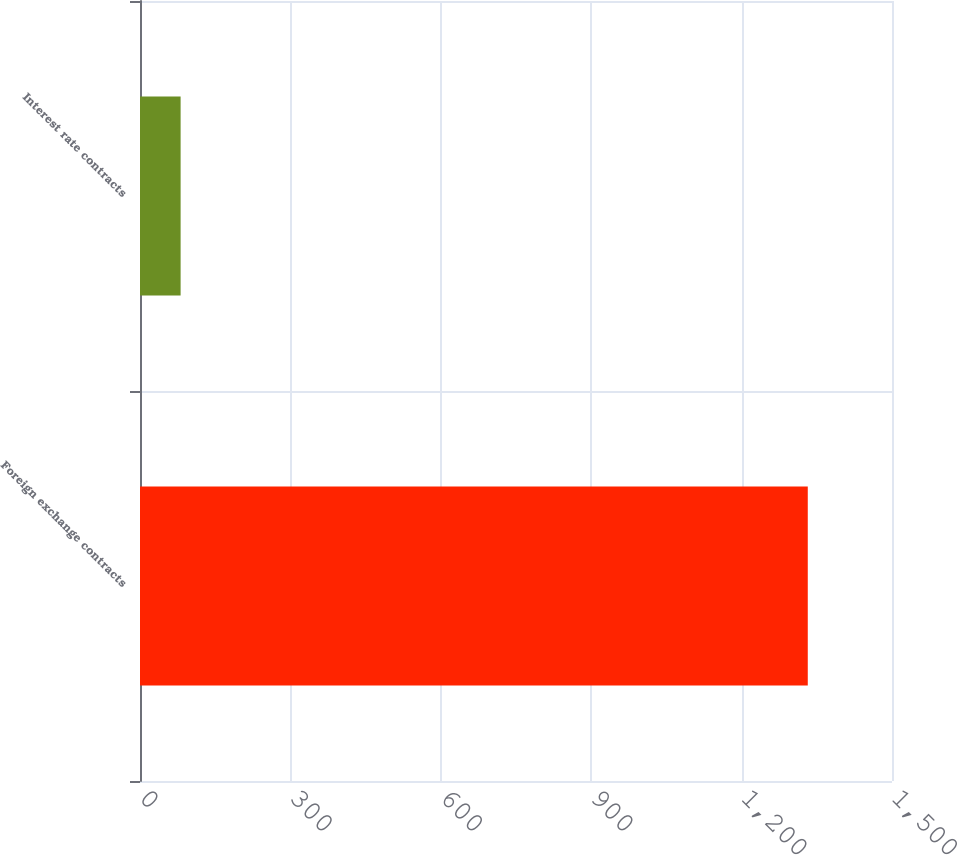Convert chart. <chart><loc_0><loc_0><loc_500><loc_500><bar_chart><fcel>Foreign exchange contracts<fcel>Interest rate contracts<nl><fcel>1332<fcel>81<nl></chart> 